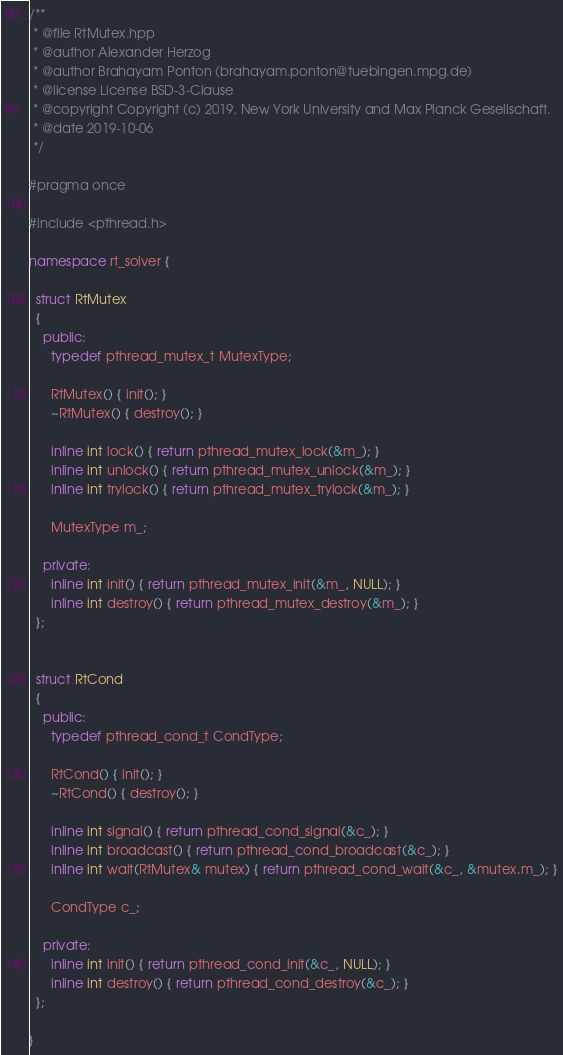<code> <loc_0><loc_0><loc_500><loc_500><_C++_>/**
 * @file RtMutex.hpp
 * @author Alexander Herzog
 * @author Brahayam Ponton (brahayam.ponton@tuebingen.mpg.de)
 * @license License BSD-3-Clause
 * @copyright Copyright (c) 2019, New York University and Max Planck Gesellschaft.
 * @date 2019-10-06
 */

#pragma once

#include <pthread.h>

namespace rt_solver {

  struct RtMutex
  {
    public:
      typedef pthread_mutex_t MutexType;

      RtMutex() { init(); }
      ~RtMutex() { destroy(); }

      inline int lock() { return pthread_mutex_lock(&m_); }
      inline int unlock() { return pthread_mutex_unlock(&m_); }
      inline int trylock() { return pthread_mutex_trylock(&m_); }

      MutexType m_;

    private:
      inline int init() { return pthread_mutex_init(&m_, NULL); }
      inline int destroy() { return pthread_mutex_destroy(&m_); }
  };


  struct RtCond
  {
    public:
      typedef pthread_cond_t CondType;

      RtCond() { init(); }
      ~RtCond() { destroy(); }

      inline int signal() { return pthread_cond_signal(&c_); }
      inline int broadcast() { return pthread_cond_broadcast(&c_); }
      inline int wait(RtMutex& mutex) { return pthread_cond_wait(&c_, &mutex.m_); }

      CondType c_;

    private:
      inline int init() { return pthread_cond_init(&c_, NULL); }
      inline int destroy() { return pthread_cond_destroy(&c_); }
  };

}
</code> 